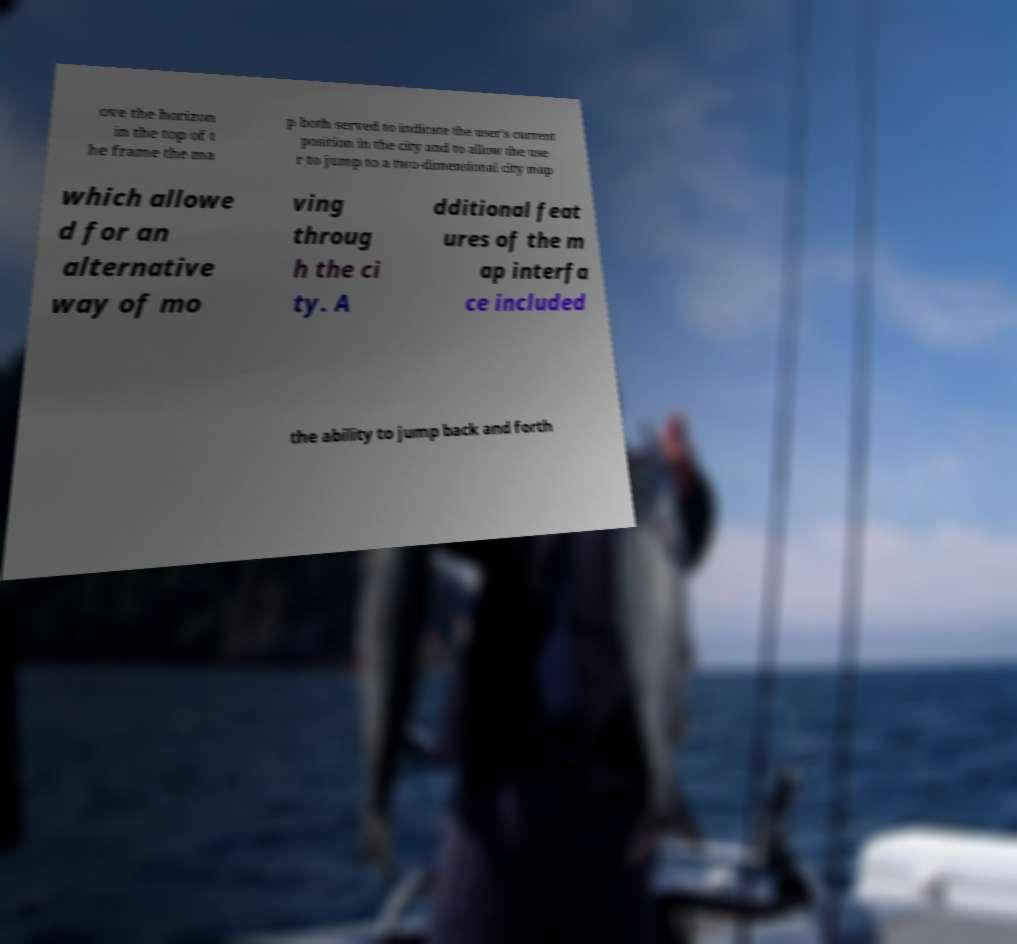Please read and relay the text visible in this image. What does it say? ove the horizon in the top of t he frame the ma p both served to indicate the user's current position in the city and to allow the use r to jump to a two-dimensional city map which allowe d for an alternative way of mo ving throug h the ci ty. A dditional feat ures of the m ap interfa ce included the ability to jump back and forth 